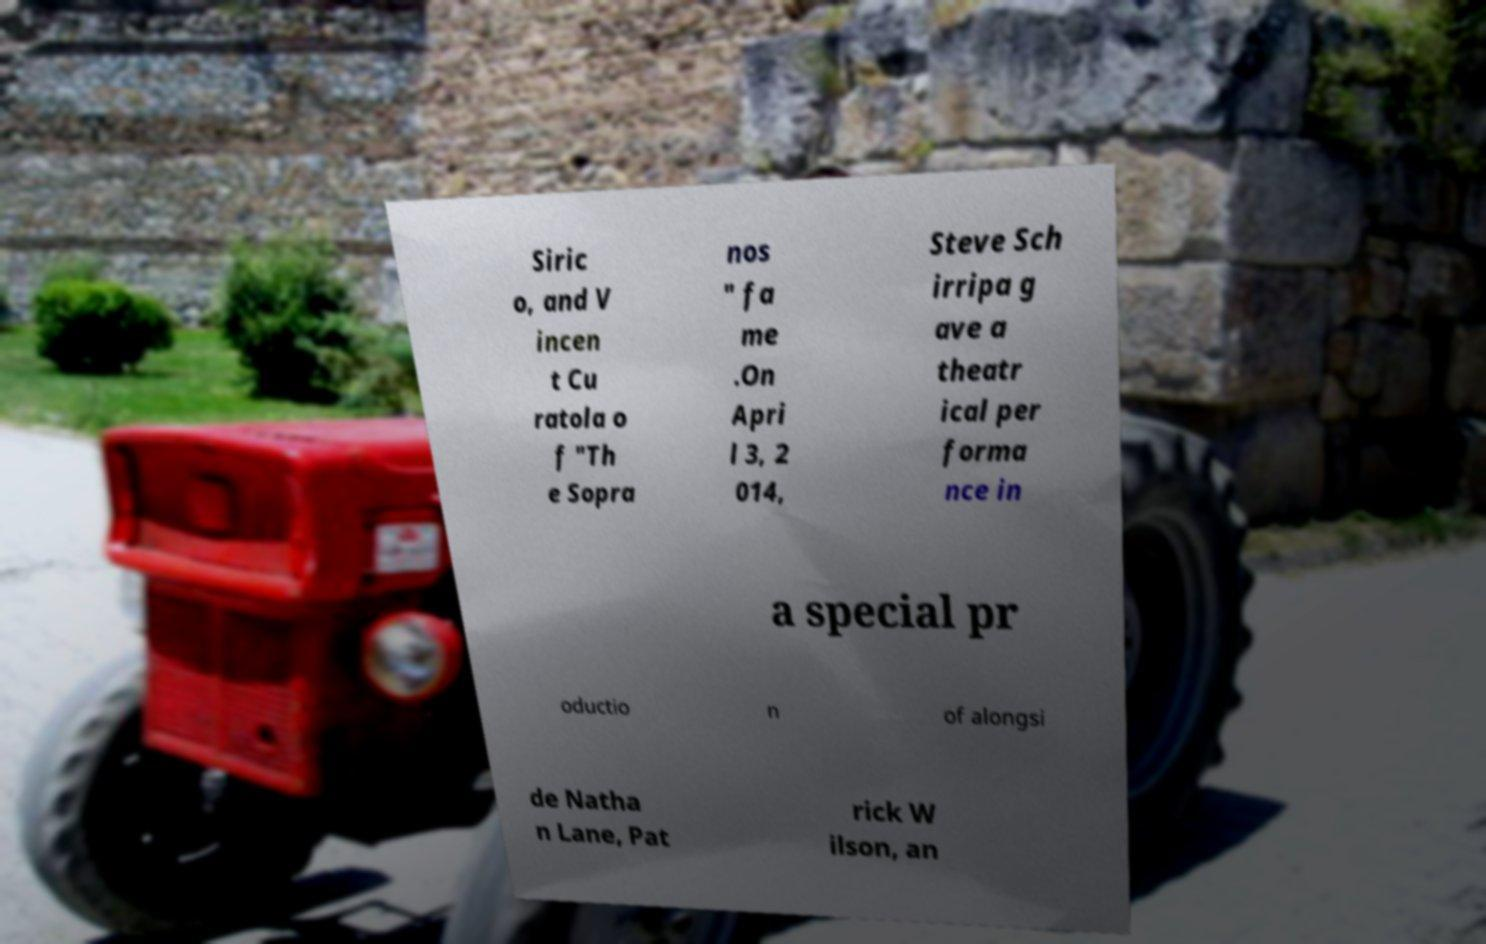Could you assist in decoding the text presented in this image and type it out clearly? Siric o, and V incen t Cu ratola o f "Th e Sopra nos " fa me .On Apri l 3, 2 014, Steve Sch irripa g ave a theatr ical per forma nce in a special pr oductio n of alongsi de Natha n Lane, Pat rick W ilson, an 